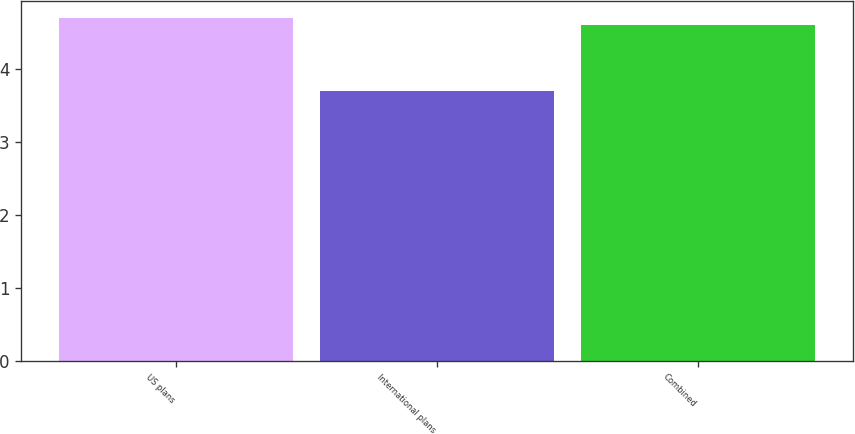Convert chart to OTSL. <chart><loc_0><loc_0><loc_500><loc_500><bar_chart><fcel>US plans<fcel>International plans<fcel>Combined<nl><fcel>4.7<fcel>3.7<fcel>4.6<nl></chart> 